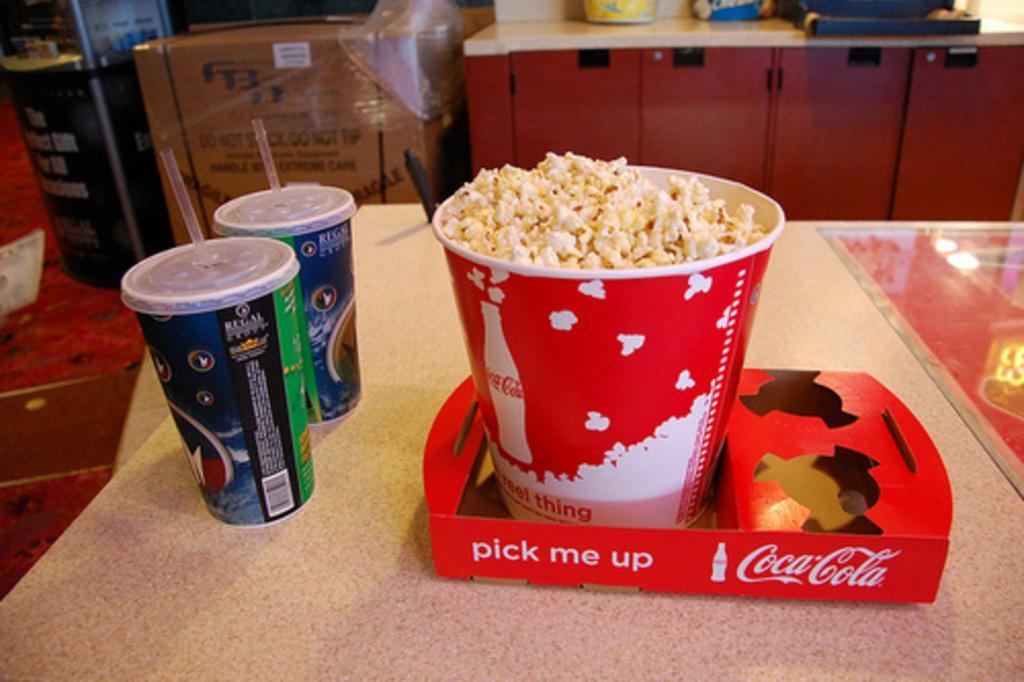In one or two sentences, can you explain what this image depicts? In this picture we can see popcorn in a tub, glasses with straws and objects on the table. In the background of the image we can see cardboard box, floor and objects. 